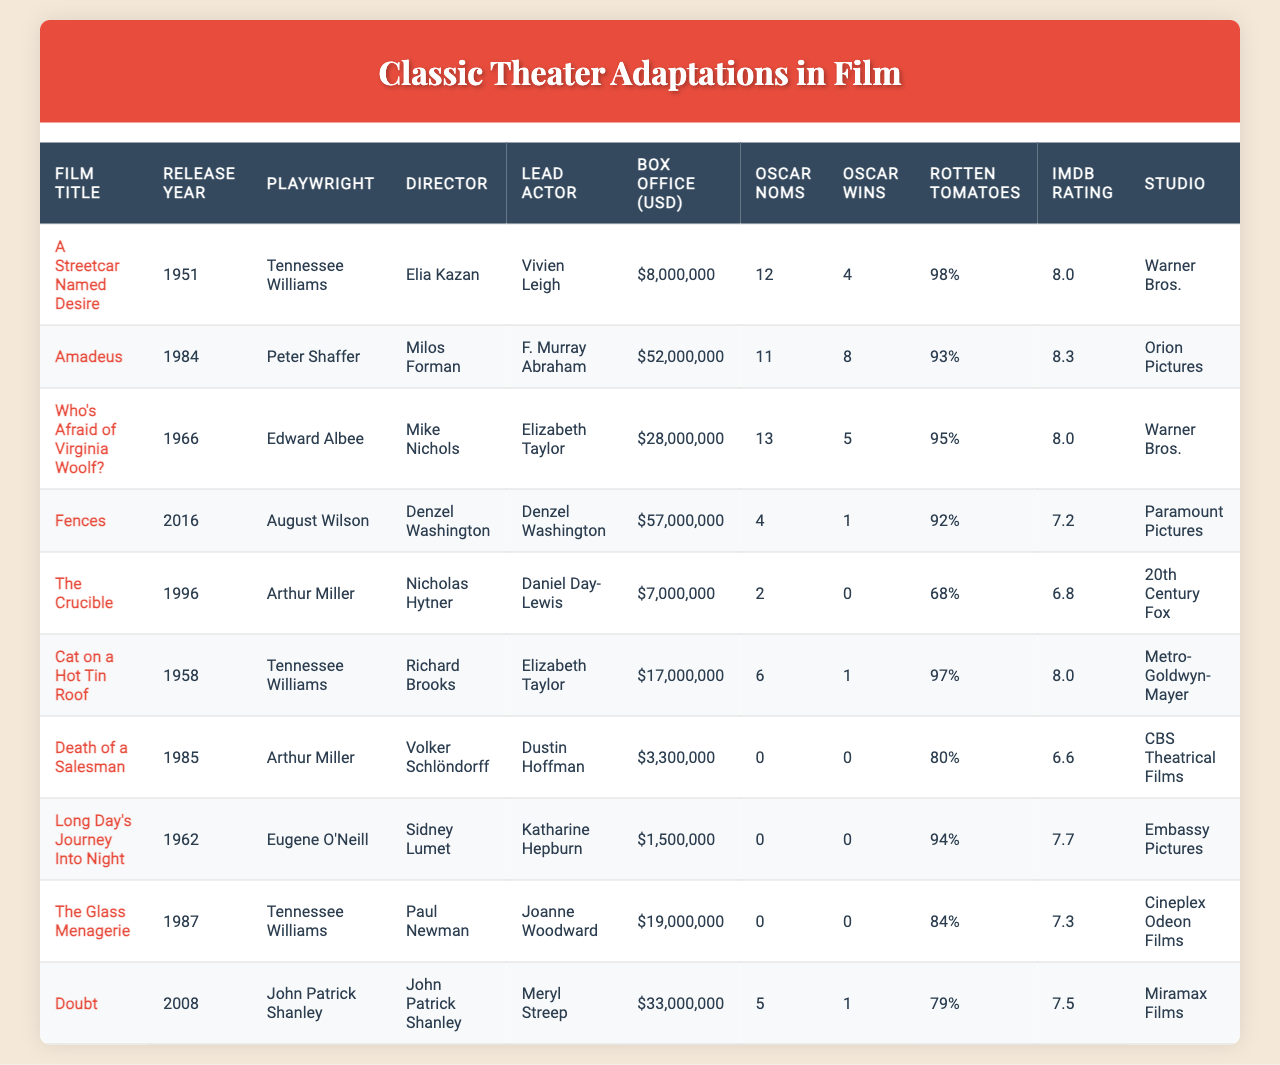What is the highest box office gross among the films listed? By examining the "Box Office (USD)" column, "Amadeus" has the highest gross with $52,000,000.
Answer: $52,000,000 Which film has the most Oscar nominations? Looking at the "Oscar Noms" column, "Who's Afraid of Virginia Woolf?" has the highest nominations with 13.
Answer: 13 How many films were released before the year 2000? Counting the "Release Year" column, 6 films were released before the year 2000: "A Streetcar Named Desire" (1951), "Cat on a Hot Tin Roof" (1958), "Who's Afraid of Virginia Woolf?" (1966), "The Crucible" (1996), "Death of a Salesman" (1985), and "Long Day's Journey Into Night" (1962).
Answer: 6 Did "A Streetcar Named Desire" win any Oscars? Checking the "Oscar Wins" column for "A Streetcar Named Desire," it won 4 Oscars. Therefore, the answer is yes.
Answer: Yes What is the average IMDb rating of the films listed? The IMDb ratings are 8.0, 8.3, 8.0, 7.2, 6.8, 8.0, 6.6, 7.7, 7.3, and 7.5. The sum of these ratings is 78.4, and dividing it by 10 gives an average of 7.84.
Answer: 7.84 Which director has the highest number of his films in this table? By reviewing the "Director" column, there are two films directed by Tennessee Williams adaptations: "A Streetcar Named Desire" and "Cat on a Hot Tin Roof." Since no other director appears more than once, Tennessee Williams is the only one with multiple adaptations.
Answer: Tennessee Williams What is the total box office gross for all films from 1980 onward? The films released from 1980 onward are "Amadeus" (1984), "Fences" (2016), "Doubt" (2008), "The Crucible" (1996), and "Who's Afraid of Virginia Woolf?" (1966). Their box office gross totals are $52,000,000, $57,000,000, $33,000,000, and $7,000,000 respectively. The total sum is $52,000,000 + $57,000,000 + $33,000,000 + $7,000,000 = $149,000,000.
Answer: $149,000,000 What percentage of films listed received an Oscar win? There are 10 films in total, and of these, 5 films received at least 1 Oscar win. To find the percentage, (5/10)*100 = 50%.
Answer: 50% Which film had the lowest Rotten Tomatoes score? Looking at the "Rotten Tomatoes" column, "The Crucible" has the lowest score at 68%.
Answer: 68% What year was the film "Doubt" released? "Doubt" is listed under the "Film Title" column and its corresponding "Release Year" is 2008.
Answer: 2008 